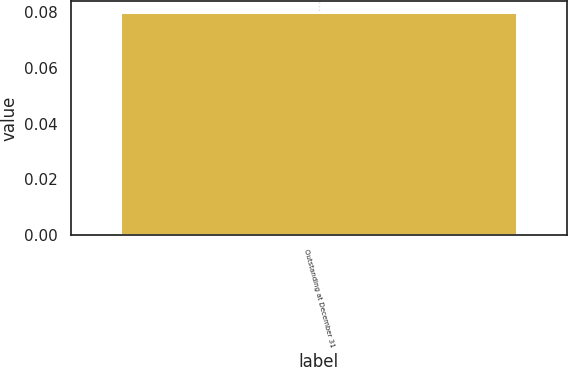Convert chart to OTSL. <chart><loc_0><loc_0><loc_500><loc_500><bar_chart><fcel>Outstanding at December 31<nl><fcel>0.08<nl></chart> 